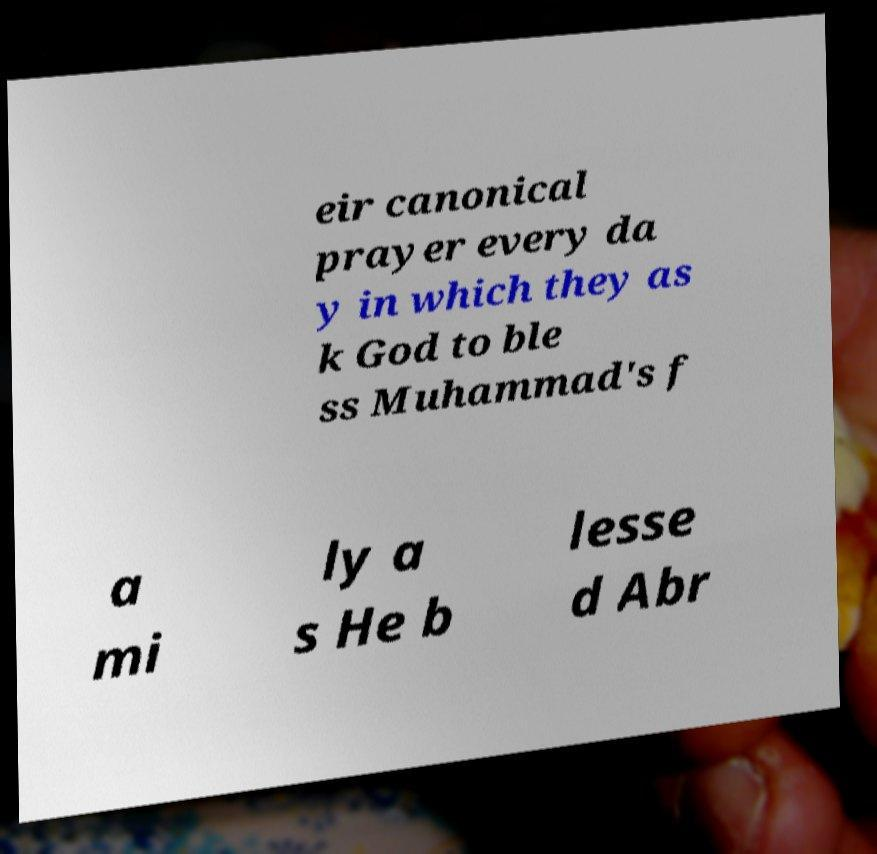Please read and relay the text visible in this image. What does it say? eir canonical prayer every da y in which they as k God to ble ss Muhammad's f a mi ly a s He b lesse d Abr 